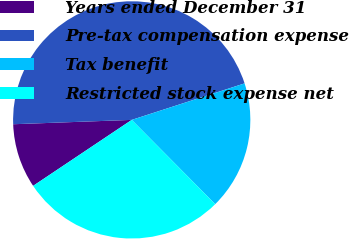Convert chart. <chart><loc_0><loc_0><loc_500><loc_500><pie_chart><fcel>Years ended December 31<fcel>Pre-tax compensation expense<fcel>Tax benefit<fcel>Restricted stock expense net<nl><fcel>8.8%<fcel>45.6%<fcel>17.55%<fcel>28.04%<nl></chart> 